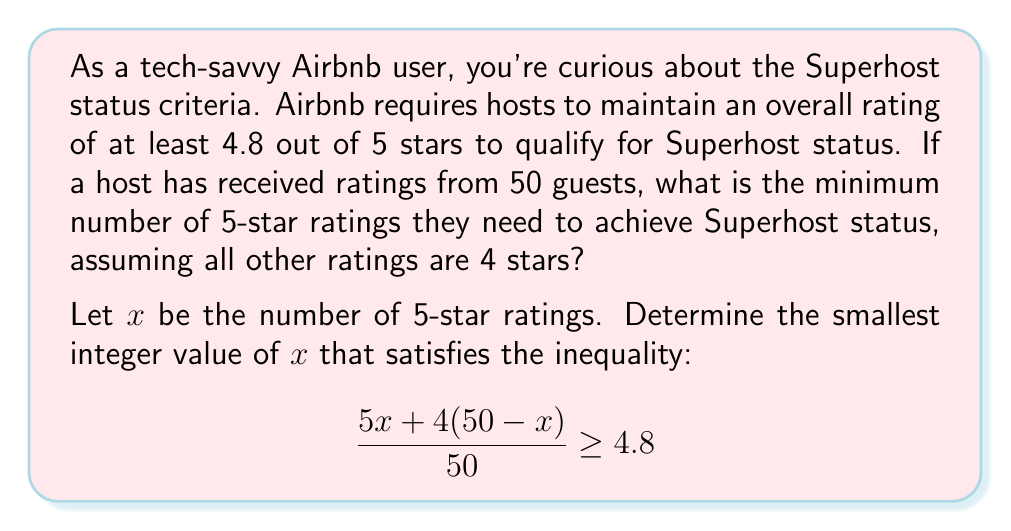Teach me how to tackle this problem. Let's approach this step-by-step:

1) First, let's set up the inequality:
   $$\frac{5x + 4(50-x)}{50} \geq 4.8$$

2) Simplify the numerator:
   $$\frac{5x + 200 - 4x}{50} \geq 4.8$$
   $$\frac{x + 200}{50} \geq 4.8$$

3) Multiply both sides by 50:
   $$x + 200 \geq 240$$

4) Subtract 200 from both sides:
   $$x \geq 40$$

5) Since $x$ represents the number of 5-star ratings, it must be an integer. Therefore, the smallest value of $x$ that satisfies this inequality is 40.

6) To verify, let's plug this back into our original inequality:
   $$\frac{5(40) + 4(50-40)}{50} = \frac{200 + 40}{50} = \frac{240}{50} = 4.8$$

This confirms that 40 is indeed the minimum number of 5-star ratings needed to achieve an overall rating of 4.8.
Answer: The minimum number of 5-star ratings needed is 40. 